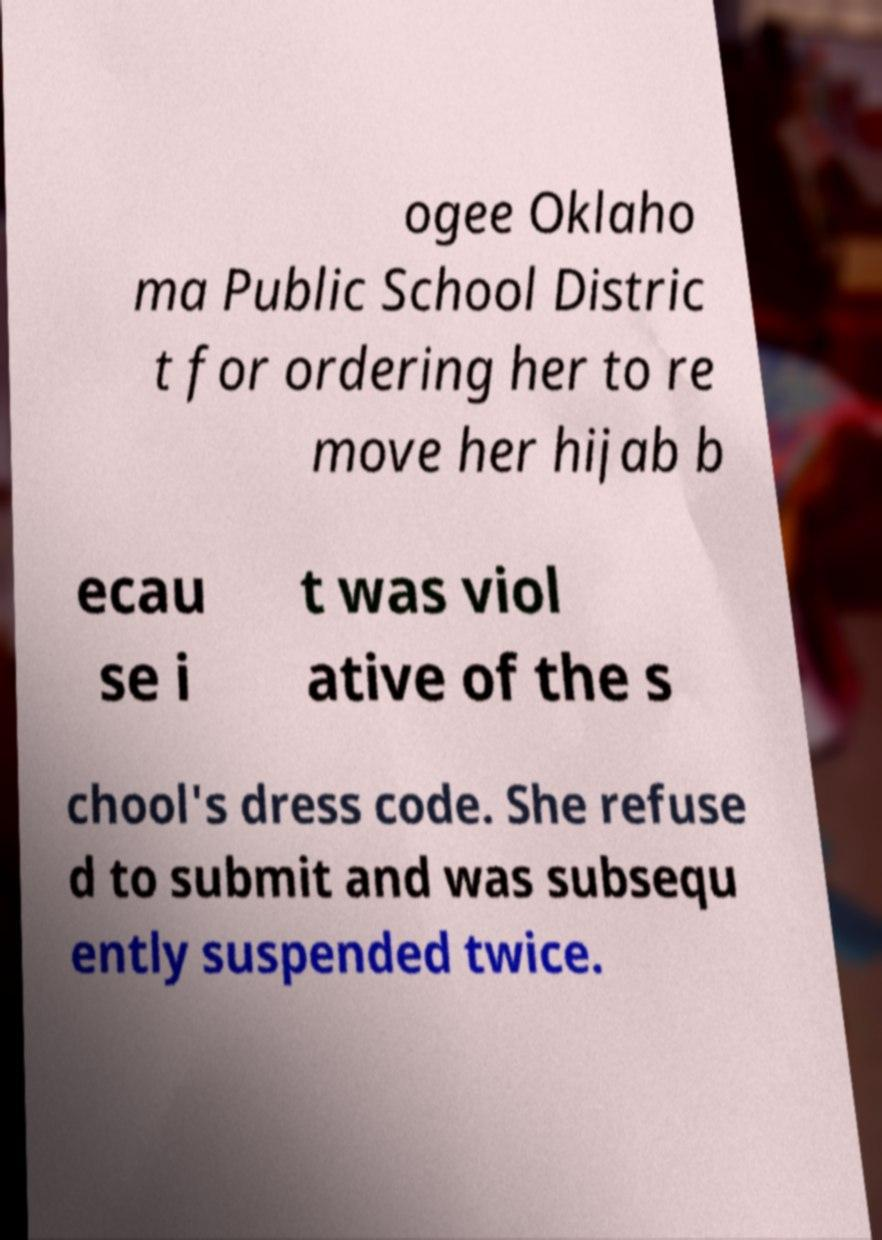Could you extract and type out the text from this image? ogee Oklaho ma Public School Distric t for ordering her to re move her hijab b ecau se i t was viol ative of the s chool's dress code. She refuse d to submit and was subsequ ently suspended twice. 